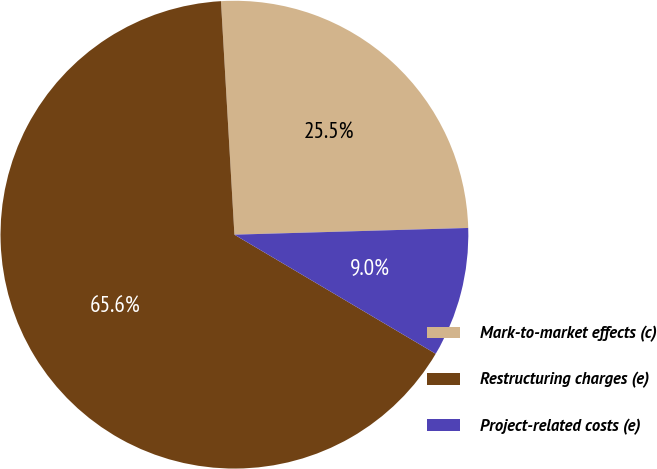Convert chart. <chart><loc_0><loc_0><loc_500><loc_500><pie_chart><fcel>Mark-to-market effects (c)<fcel>Restructuring charges (e)<fcel>Project-related costs (e)<nl><fcel>25.46%<fcel>65.58%<fcel>8.96%<nl></chart> 